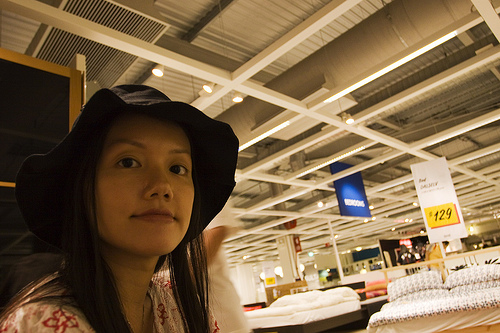<image>
Is the bed behind the woman? Yes. From this viewpoint, the bed is positioned behind the woman, with the woman partially or fully occluding the bed. 